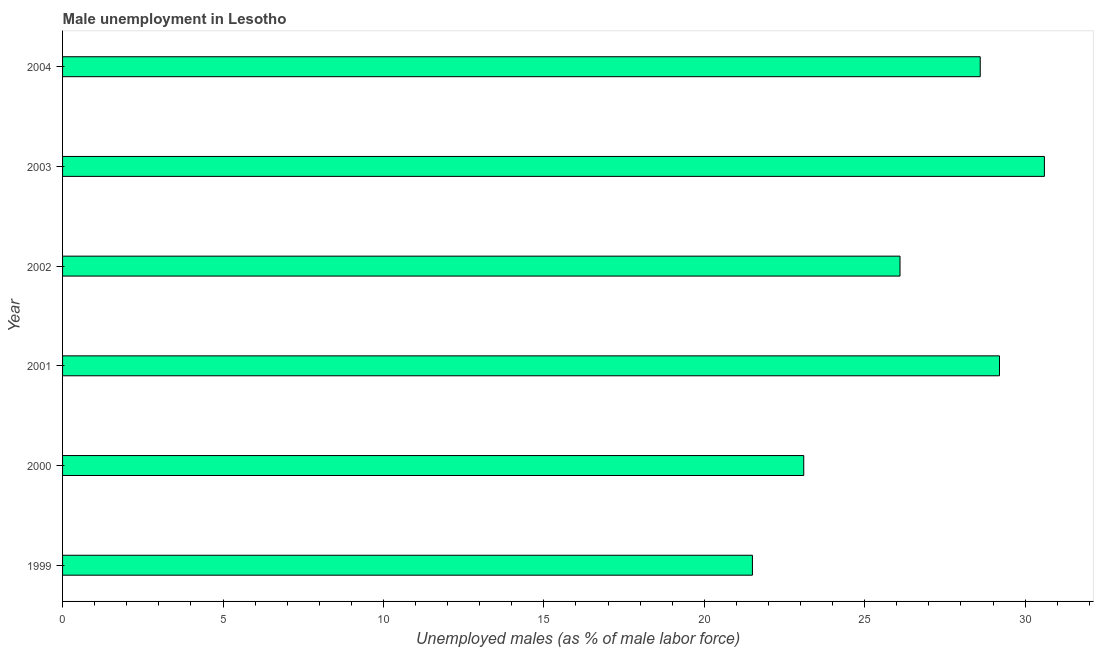Does the graph contain any zero values?
Give a very brief answer. No. What is the title of the graph?
Give a very brief answer. Male unemployment in Lesotho. What is the label or title of the X-axis?
Your response must be concise. Unemployed males (as % of male labor force). What is the label or title of the Y-axis?
Offer a very short reply. Year. What is the unemployed males population in 2000?
Your answer should be compact. 23.1. Across all years, what is the maximum unemployed males population?
Ensure brevity in your answer.  30.6. Across all years, what is the minimum unemployed males population?
Give a very brief answer. 21.5. In which year was the unemployed males population maximum?
Give a very brief answer. 2003. In which year was the unemployed males population minimum?
Offer a terse response. 1999. What is the sum of the unemployed males population?
Provide a short and direct response. 159.1. What is the average unemployed males population per year?
Provide a short and direct response. 26.52. What is the median unemployed males population?
Give a very brief answer. 27.35. In how many years, is the unemployed males population greater than 25 %?
Your response must be concise. 4. Do a majority of the years between 1999 and 2000 (inclusive) have unemployed males population greater than 22 %?
Your response must be concise. No. What is the ratio of the unemployed males population in 2000 to that in 2002?
Ensure brevity in your answer.  0.89. What is the difference between the highest and the lowest unemployed males population?
Your answer should be compact. 9.1. In how many years, is the unemployed males population greater than the average unemployed males population taken over all years?
Give a very brief answer. 3. How many years are there in the graph?
Keep it short and to the point. 6. What is the Unemployed males (as % of male labor force) in 2000?
Offer a terse response. 23.1. What is the Unemployed males (as % of male labor force) of 2001?
Offer a terse response. 29.2. What is the Unemployed males (as % of male labor force) of 2002?
Offer a very short reply. 26.1. What is the Unemployed males (as % of male labor force) in 2003?
Give a very brief answer. 30.6. What is the Unemployed males (as % of male labor force) in 2004?
Provide a short and direct response. 28.6. What is the difference between the Unemployed males (as % of male labor force) in 1999 and 2004?
Provide a succinct answer. -7.1. What is the difference between the Unemployed males (as % of male labor force) in 2000 and 2002?
Provide a short and direct response. -3. What is the difference between the Unemployed males (as % of male labor force) in 2000 and 2003?
Make the answer very short. -7.5. What is the difference between the Unemployed males (as % of male labor force) in 2002 and 2003?
Keep it short and to the point. -4.5. What is the difference between the Unemployed males (as % of male labor force) in 2002 and 2004?
Provide a short and direct response. -2.5. What is the ratio of the Unemployed males (as % of male labor force) in 1999 to that in 2001?
Your answer should be very brief. 0.74. What is the ratio of the Unemployed males (as % of male labor force) in 1999 to that in 2002?
Make the answer very short. 0.82. What is the ratio of the Unemployed males (as % of male labor force) in 1999 to that in 2003?
Make the answer very short. 0.7. What is the ratio of the Unemployed males (as % of male labor force) in 1999 to that in 2004?
Offer a terse response. 0.75. What is the ratio of the Unemployed males (as % of male labor force) in 2000 to that in 2001?
Ensure brevity in your answer.  0.79. What is the ratio of the Unemployed males (as % of male labor force) in 2000 to that in 2002?
Give a very brief answer. 0.89. What is the ratio of the Unemployed males (as % of male labor force) in 2000 to that in 2003?
Provide a short and direct response. 0.76. What is the ratio of the Unemployed males (as % of male labor force) in 2000 to that in 2004?
Your answer should be very brief. 0.81. What is the ratio of the Unemployed males (as % of male labor force) in 2001 to that in 2002?
Provide a succinct answer. 1.12. What is the ratio of the Unemployed males (as % of male labor force) in 2001 to that in 2003?
Provide a short and direct response. 0.95. What is the ratio of the Unemployed males (as % of male labor force) in 2002 to that in 2003?
Your response must be concise. 0.85. What is the ratio of the Unemployed males (as % of male labor force) in 2002 to that in 2004?
Keep it short and to the point. 0.91. What is the ratio of the Unemployed males (as % of male labor force) in 2003 to that in 2004?
Make the answer very short. 1.07. 